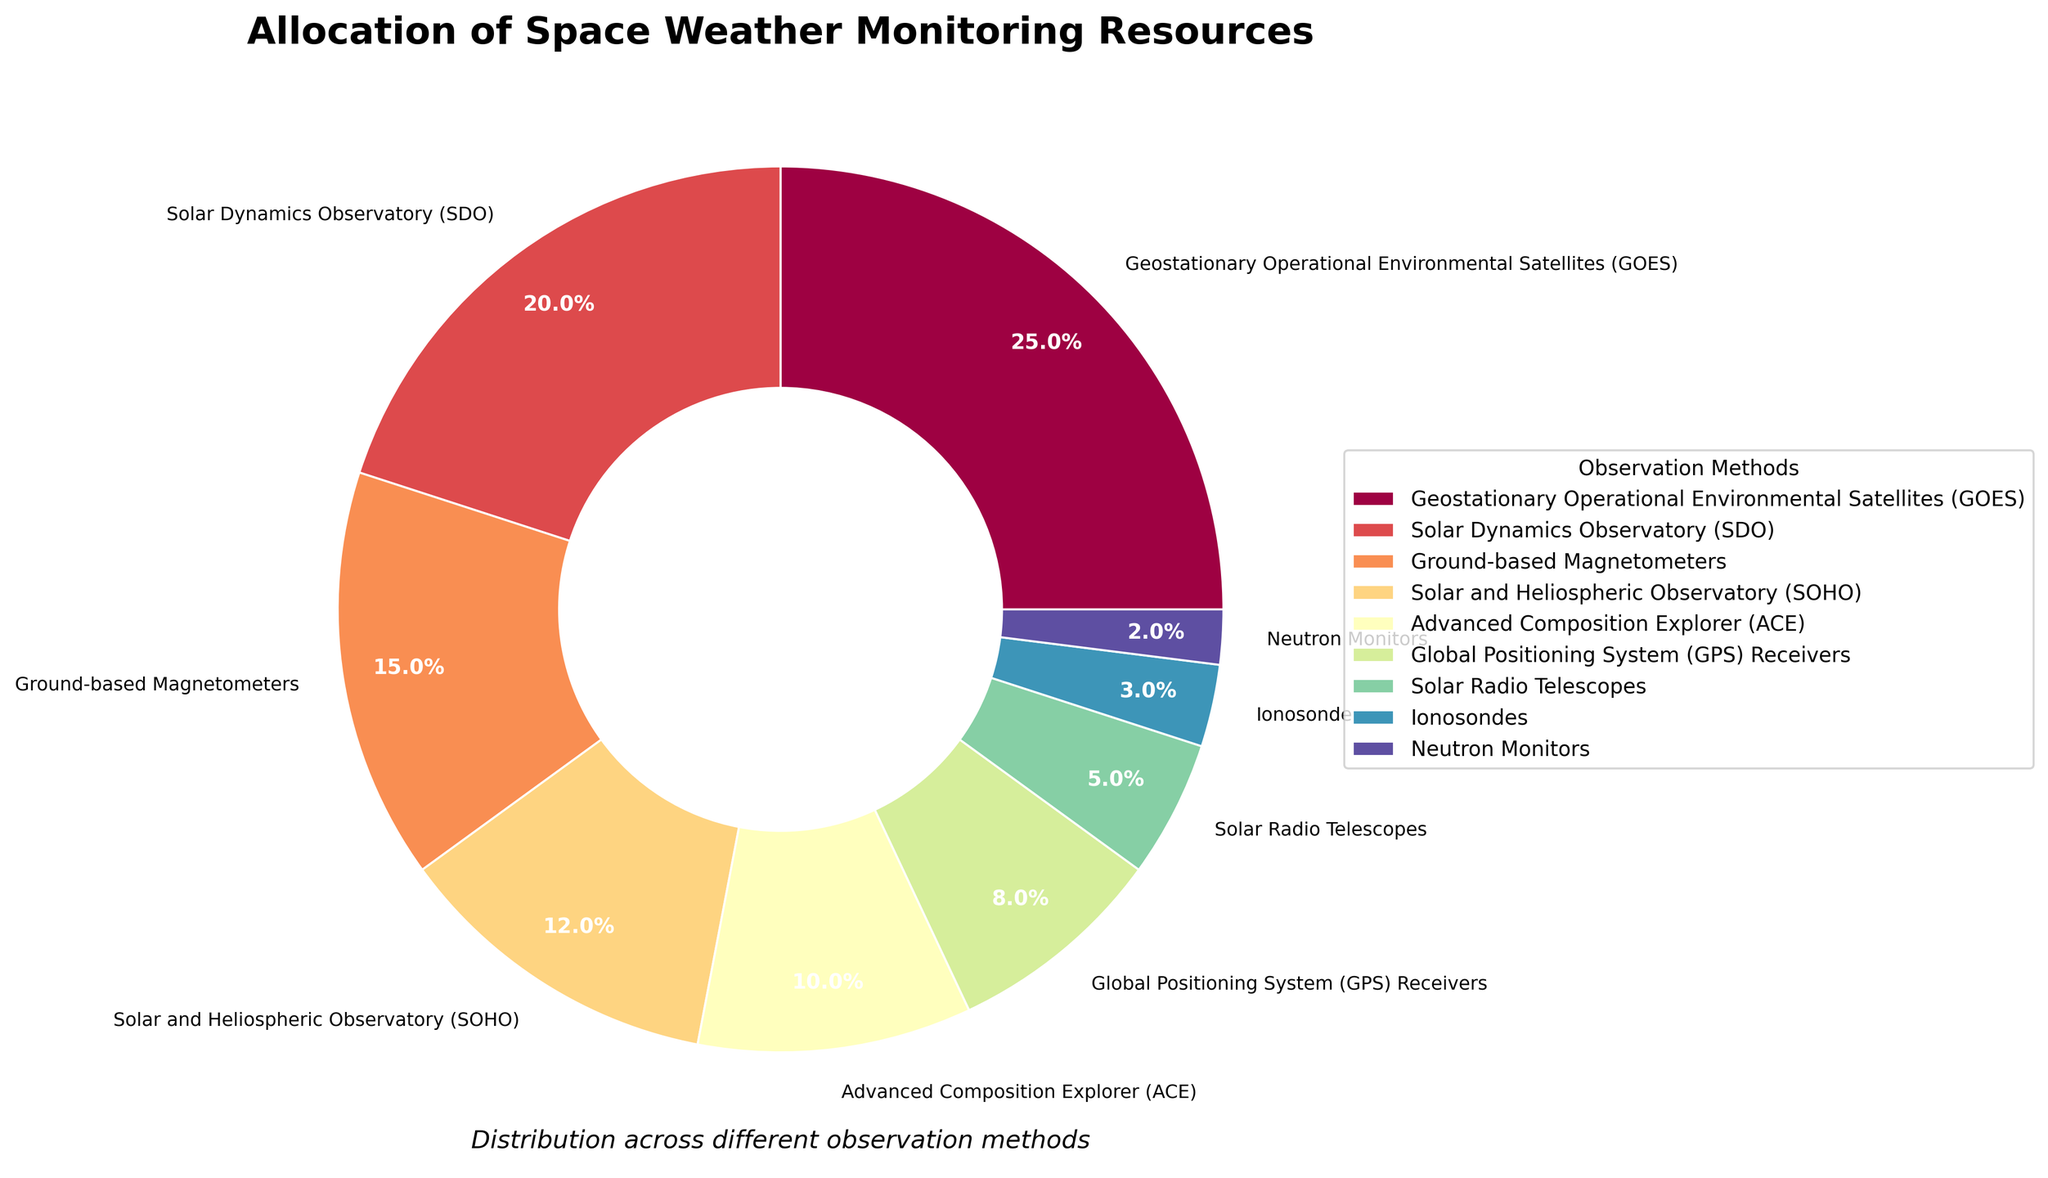What's the observation method with the largest resource allocation percentage? The pie chart shows the percentage of resources allocated to each observation method. The Geostationary Operational Environmental Satellites (GOES) segment is the largest, constituting 25% of the total.
Answer: Geostationary Operational Environmental Satellites (GOES) What’s the combined percentage for ground-based instruments (Ground-based Magnetometers, Global Positioning System (GPS) Receivers, Solar Radio Telescopes, Ionosondes, and Neutron Monitors)? Sum the percentages of all the ground-based instruments: Ground-based Magnetometers (15%) + Global Positioning System (GPS) Receivers (8%) + Solar Radio Telescopes (5%) + Ionosondes (3%) + Neutron Monitors (2%). The total is 15% + 8% + 5% + 3% + 2% = 33%.
Answer: 33% Which observation method has the smallest resource allocation? By examining the pie chart, the smallest wedge corresponds to Neutron Monitors, which has the smallest percentage at 2%.
Answer: Neutron Monitors How much more resources are allocated to the Solar Dynamics Observatory (SDO) compared to the Advanced Composition Explorer (ACE)? The Solar Dynamics Observatory (SDO) has 20% allocation while the Advanced Composition Explorer (ACE) has 10%. The difference is 20% - 10% = 10%.
Answer: 10% What is the median percentage of resource allocation across all methods? First, list the percentages: 2%, 3%, 5%, 8%, 10%, 12%, 15%, 20%, and 25%. The median is the middle value, which in this case is 10% (Advanced Composition Explorer (ACE)).
Answer: 10% By how much does the percentage of resources allocated to Solar and Heliospheric Observatory (SOHO) exceed that of Solar Radio Telescopes? Solar and Heliospheric Observatory (SOHO) has a 12% allocation, and Solar Radio Telescopes have a 5% allocation. The difference is 12% - 5% = 7%.
Answer: 7% Which visual attributes help identify the Solar Dynamics Observatory (SDO) segment in the pie chart? The Solar Dynamics Observatory (SDO) segment is depicted using a specific color. Each wedge has labels and percentages displayed clearly, helping to identify the SDO's allocation of 20%.
Answer: Label "Solar Dynamics Observatory (SDO)" with a specific color What’s the total percentage allocated to the top two observation methods combined? The top two observation methods are Geostationary Operational Environmental Satellites (GOES) at 25% and Solar Dynamics Observatory (SDO) at 20%. Summing these percentages: 25% + 20% = 45%.
Answer: 45% Which method has a resource allocation that is closest to twice the allocation of Global Positioning System (GPS) Receivers? Global Positioning System (GPS) Receivers have an 8% allocation. Twice this is 16%. The closest method allocation is Ground-based Magnetometers at 15%.
Answer: Ground-based Magnetometers (15%) Is the percentage of resources allocated to Ionosondes more or less than half of that allocated to the Solar Dynamics Observatory (SDO)? The Solar Dynamics Observatory (SDO) has a 20% allocation. Half of this is 10%. Ionosondes have 3%, which is less than half of 20%.
Answer: Less 